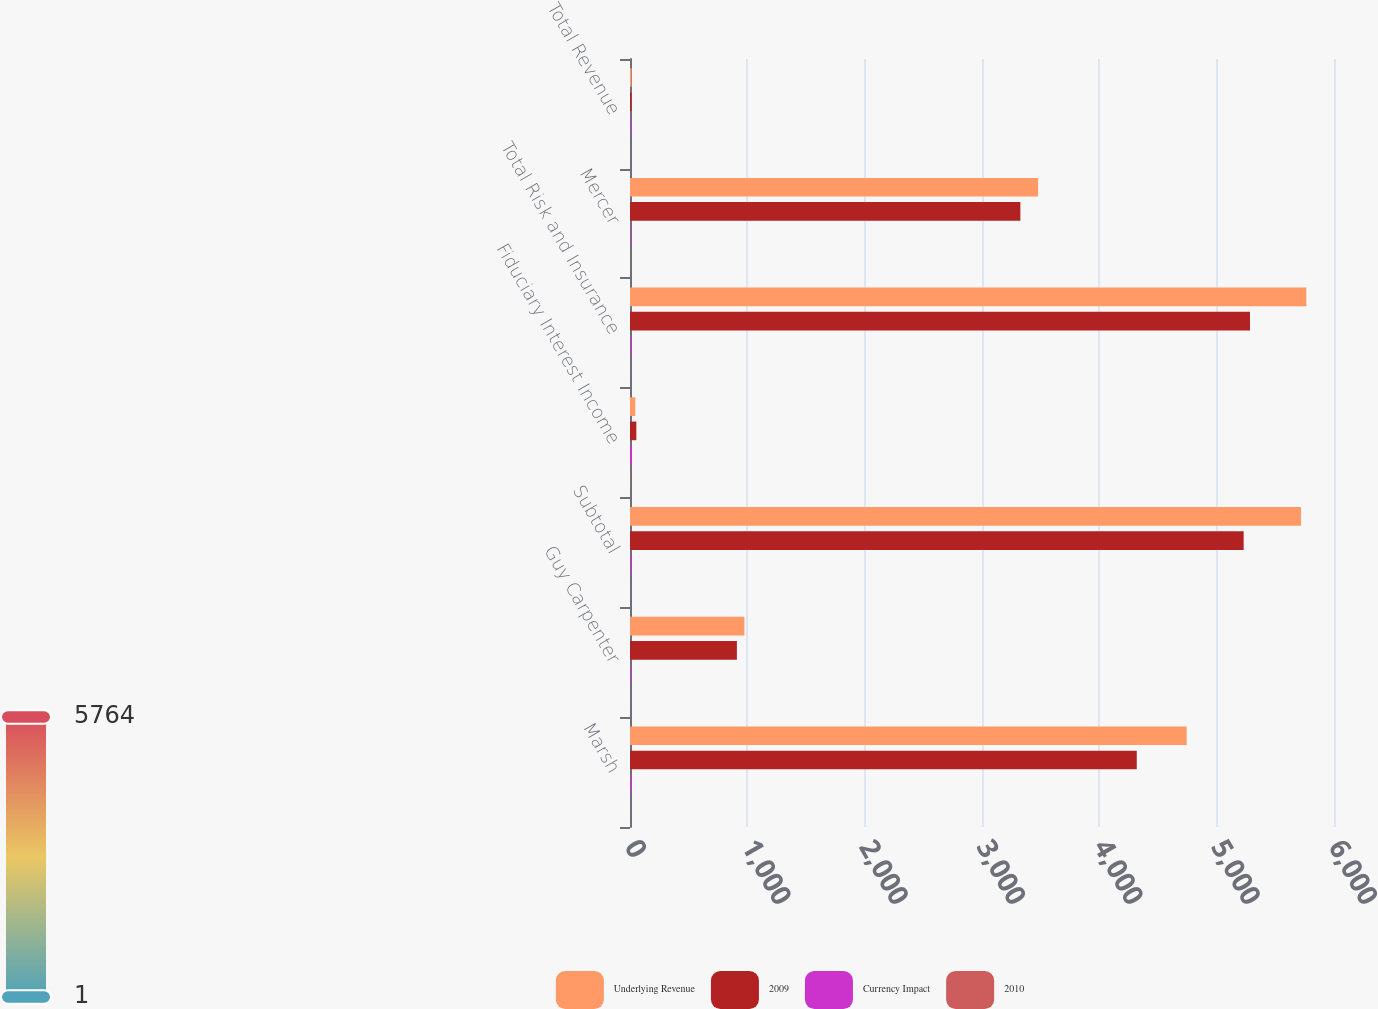<chart> <loc_0><loc_0><loc_500><loc_500><stacked_bar_chart><ecel><fcel>Marsh<fcel>Guy Carpenter<fcel>Subtotal<fcel>Fiduciary Interest Income<fcel>Total Risk and Insurance<fcel>Mercer<fcel>Total Revenue<nl><fcel>Underlying Revenue<fcel>4744<fcel>975<fcel>5719<fcel>45<fcel>5764<fcel>3478<fcel>13<nl><fcel>2009<fcel>4319<fcel>911<fcel>5230<fcel>54<fcel>5284<fcel>3327<fcel>13<nl><fcel>Currency Impact<fcel>10<fcel>7<fcel>9<fcel>16<fcel>9<fcel>5<fcel>7<nl><fcel>2010<fcel>1<fcel>1<fcel>1<fcel>3<fcel>1<fcel>2<fcel>1<nl></chart> 